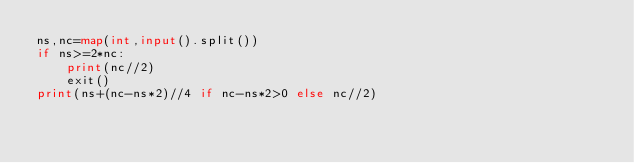<code> <loc_0><loc_0><loc_500><loc_500><_Python_>ns,nc=map(int,input().split())
if ns>=2*nc:
    print(nc//2)
    exit()
print(ns+(nc-ns*2)//4 if nc-ns*2>0 else nc//2)
</code> 